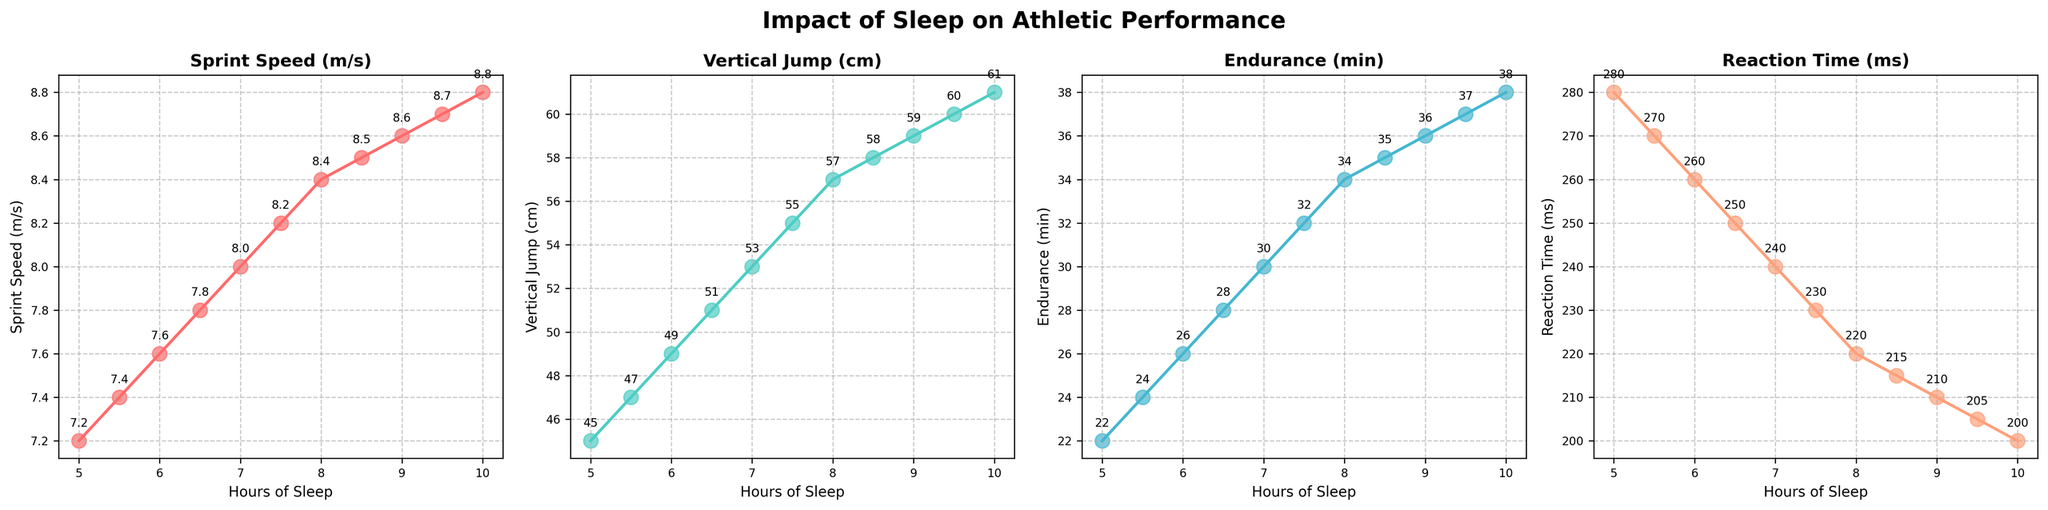How does Sprint Speed change with increasing Hours of Sleep? The figure shows a clear increasing trend in Sprint Speed as Hours of Sleep increase. As we move from left to right along the x-axis, the points on the plot for Sprint Speed are progressively getting higher, indicating that more sleep generally means faster Sprint Speed.
Answer: Sprint Speed increases Compare the Vertical Jump of athletes who get 6 hours of sleep and those who get 9 hours. According to the scatter plot for Vertical Jump, at 6 hours of sleep, the jump height is 49 cm. At 9 hours, it is 59 cm. Subtracting these values gives the difference: 59 cm - 49 cm = 10 cm.
Answer: 10 cm Which athletic performance metric shows the most improvement with increased Hours of Sleep? By visually comparing the slopes of the plots for each metric, it can be noted that Reaction Time shows the sharpest downward trend. This means it improves the most (lower Reaction Time is better).
Answer: Reaction Time What is the average Endurance time for athletes getting between 7 and 8 hours of sleep? The data for Endurance at 7 hrs and 7.5 hrs of sleep is 30 min and 32 min respectively. Adding these two together gives 62 min. Dividing by the number of data points (2) gives an average end of 62/2 = 31 min.
Answer: 31 min At what point does the Vertical Jump plateau based on the visual plot? Observing the scatter plot for Vertical Jump, the values seem to level off or plateau around 8.5 hours, where the jump height reaches 58 cm and doesn’t increase as significantly after this point compared to prior increases.
Answer: 8.5 hours Which metric appears to be most consistent in its relationship to Hours of Sleep? Comparing the visual spread and cluster consistency of all plots, Sprint Speed shows a steady and consistent increase with respect to increasing Hours of Sleep, suggesting a strong and stable relationship.
Answer: Sprint Speed What effect does sleeping less than 6 hours have on Reaction Time? According to the Reaction Time plot, when Hours of Sleep are less than 6, the Reaction Time is around 270-280 ms. As sleep increases beyond 6 hours, Reaction Time decreases.
Answer: Increased Reaction Time How does the performance metric for Endurance change between 6 hours and 9.5 hours of sleep? From the endurance plot, at 6 hours, the value is 26 minutes, and at 9.5 hours, it is 37 minutes. The change is calculated by subtracting 26 from 37, resulting in an 11-minute increase.
Answer: 11 minutes 